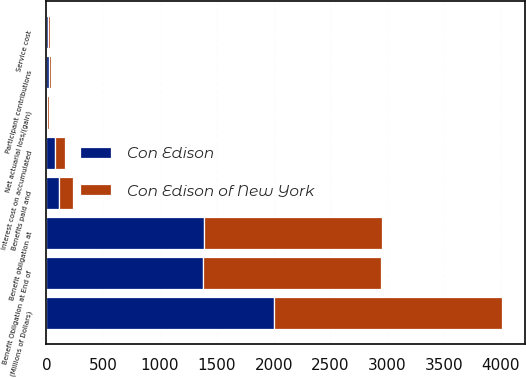Convert chart to OTSL. <chart><loc_0><loc_0><loc_500><loc_500><stacked_bar_chart><ecel><fcel>(Millions of Dollars)<fcel>Benefit obligation at<fcel>Service cost<fcel>Interest cost on accumulated<fcel>Net actuarial loss/(gain)<fcel>Benefits paid and<fcel>Participant contributions<fcel>Benefit Obligation at End of<nl><fcel>Con Edison of New York<fcel>2006<fcel>1568<fcel>17<fcel>87<fcel>17<fcel>121<fcel>20<fcel>1566<nl><fcel>Con Edison<fcel>2006<fcel>1383<fcel>13<fcel>77<fcel>9<fcel>110<fcel>19<fcel>1376<nl></chart> 